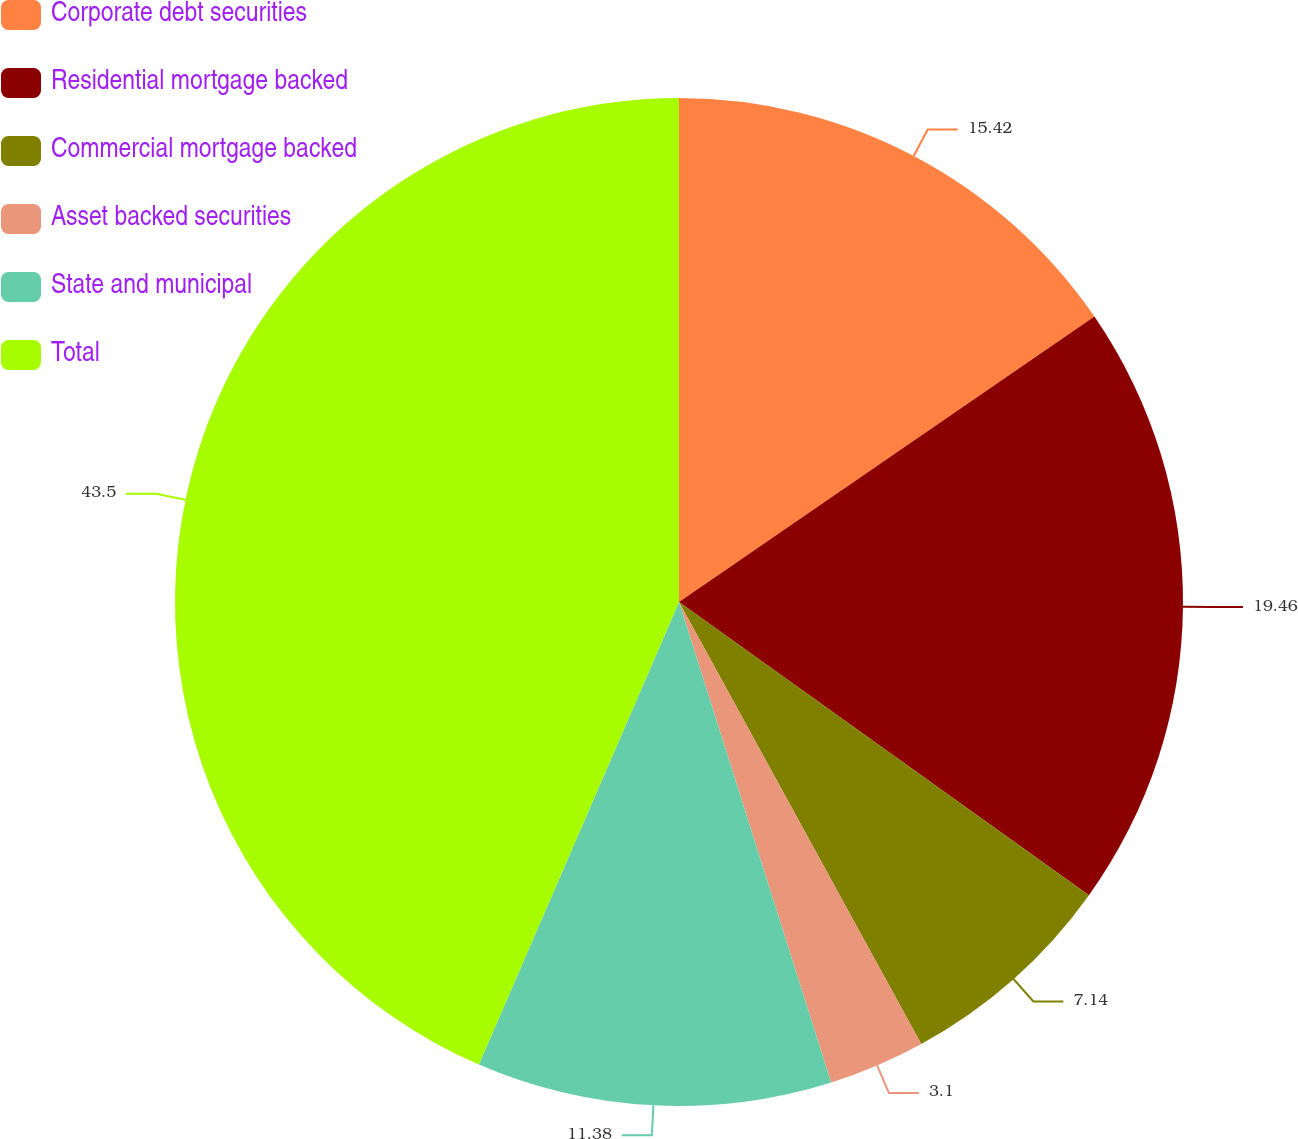Convert chart. <chart><loc_0><loc_0><loc_500><loc_500><pie_chart><fcel>Corporate debt securities<fcel>Residential mortgage backed<fcel>Commercial mortgage backed<fcel>Asset backed securities<fcel>State and municipal<fcel>Total<nl><fcel>15.42%<fcel>19.46%<fcel>7.14%<fcel>3.1%<fcel>11.38%<fcel>43.5%<nl></chart> 